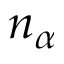Convert formula to latex. <formula><loc_0><loc_0><loc_500><loc_500>n _ { \alpha }</formula> 